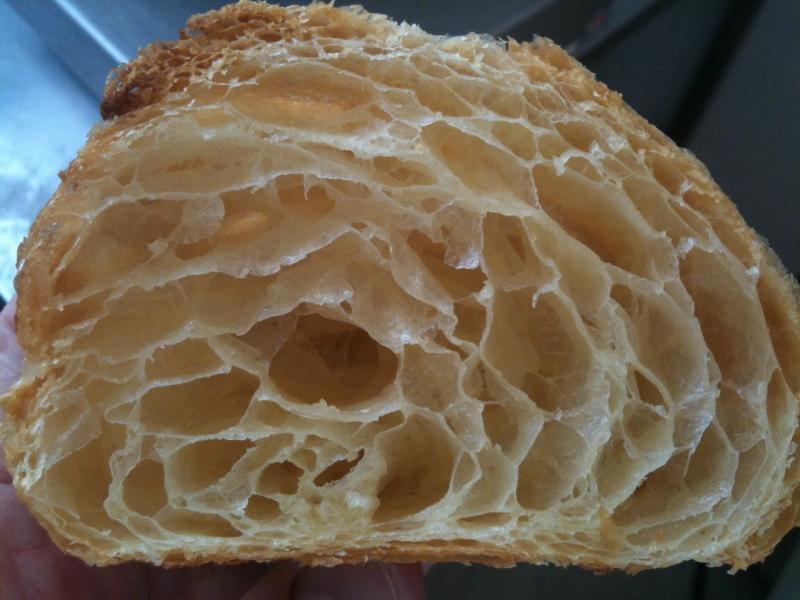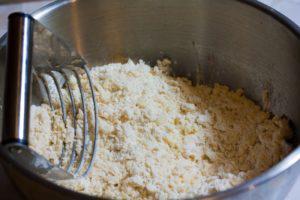The first image is the image on the left, the second image is the image on the right. Assess this claim about the two images: "A metal utinsil is near the baking ingredients in the image on the right.". Correct or not? Answer yes or no. Yes. The first image is the image on the left, the second image is the image on the right. Evaluate the accuracy of this statement regarding the images: "a piece of bread that is cut in half is showing all the layers and bubbles inside". Is it true? Answer yes or no. Yes. 